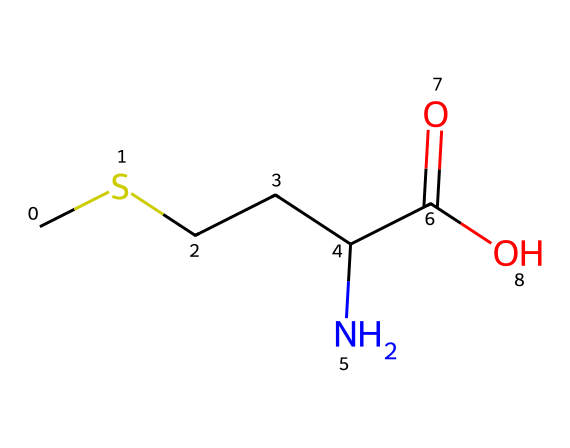What is the total number of carbon atoms in methionine? The SMILES representation indicates the presence of four carbon atoms (C), as seen in the string "CSCCC". Count each "C" in the structure to arrive at the total.
Answer: 4 How many nitrogen atoms are present in methionine? In the SMILES representation, there is one nitrogen atom denoted by "N". Therefore, only one nitrogen atom is present in the structure.
Answer: 1 What type of functional group is indicated by "C(=O)O"? The "C(=O)O" part represents a carboxylic acid functional group, characterized by a carbon atom double-bonded to an oxygen atom and single-bonded to a hydroxyl group (–OH).
Answer: carboxylic acid What is the significance of the sulfur atom in this structure? The sulfur atom (S) is crucial as it contributes to the unique properties of methionine, such as its role in protein synthesis and as a precursor for other important biomolecules. The presence of sulfur distinguishes it as a sulfur-containing amino acid.
Answer: protein synthesis How do you determine if this compound is an amino acid? The SMILES representation includes "NH" indicating an amine group (–NH2), which is a key characteristic of amino acids. Additionally, it has a carboxylic acid group, which is another defining feature of amino acids.
Answer: amine group What is the total number of oxygen atoms in methionine? By examining the "C(=O)O" part of the SMILES, we see that there are two oxygen atoms present in the carboxylic acid functional group. Therefore, the total number of oxygen atoms is two.
Answer: 2 